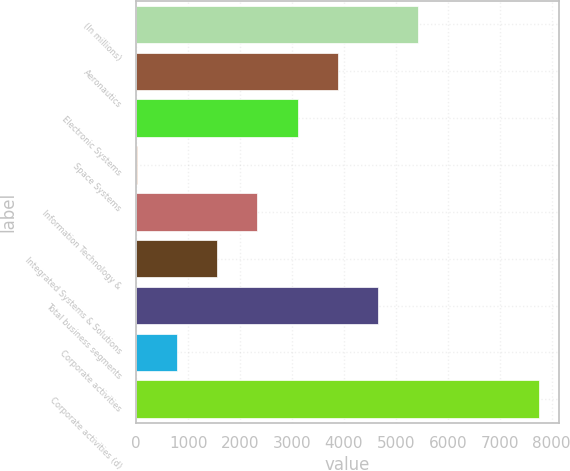<chart> <loc_0><loc_0><loc_500><loc_500><bar_chart><fcel>(In millions)<fcel>Aeronautics<fcel>Electronic Systems<fcel>Space Systems<fcel>Information Technology &<fcel>Integrated Systems & Solutions<fcel>Total business segments<fcel>Corporate activities<fcel>Corporate activities (d)<nl><fcel>5430.2<fcel>3881<fcel>3106.4<fcel>8<fcel>2331.8<fcel>1557.2<fcel>4655.6<fcel>782.6<fcel>7754<nl></chart> 